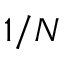Convert formula to latex. <formula><loc_0><loc_0><loc_500><loc_500>1 / N</formula> 